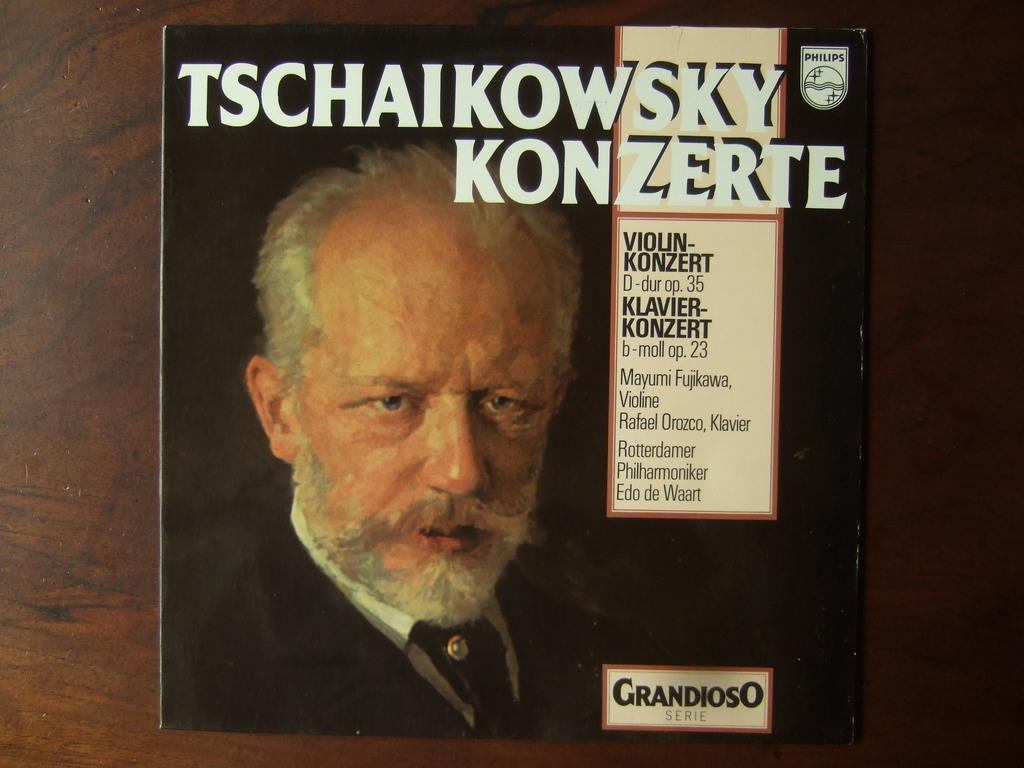What is the main object in the image? There is a board in the image. What is shown on the board? The board has a man depicted on it. Are there any words or letters on the board? Yes, there is text on the board. What is the board resting on? The board is on a wooden surface. How many toes can be seen on the man depicted on the board? There are no toes visible on the man depicted on the board; only the man's body and the text on the board are present. 